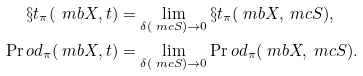Convert formula to latex. <formula><loc_0><loc_0><loc_500><loc_500>\S t _ { \pi } ( \ m b { X } , t ) & = \lim _ { \delta ( \ m c { S } ) \rightarrow 0 } \S t _ { \pi } ( \ m b { X } , \ m c { S } ) , \\ \Pr o d _ { \pi } ( \ m b { X } , t ) & = \lim _ { \delta ( \ m c { S } ) \rightarrow 0 } \Pr o d _ { \pi } ( \ m b { X } , \ m c { S } ) .</formula> 